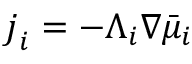Convert formula to latex. <formula><loc_0><loc_0><loc_500><loc_500>\boldsymbol j _ { i } = - \Lambda _ { i } \nabla \bar { \mu } _ { i }</formula> 